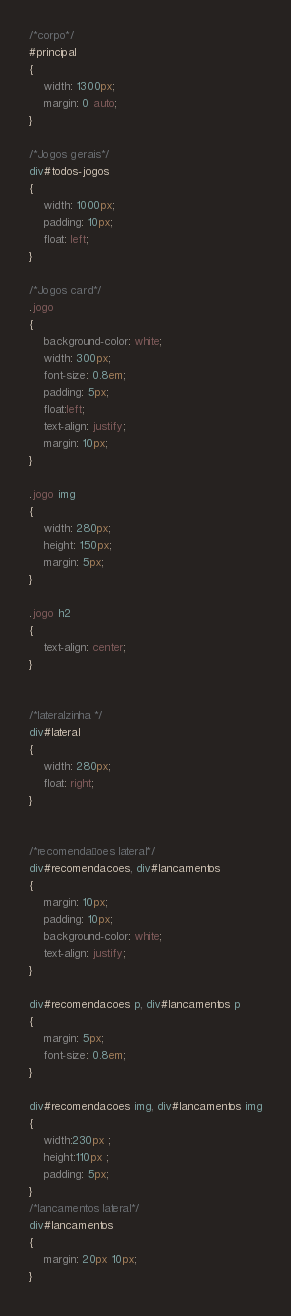Convert code to text. <code><loc_0><loc_0><loc_500><loc_500><_CSS_>
/*corpo*/
#principal
{
    width: 1300px;
    margin: 0 auto;
}

/*Jogos gerais*/
div#todos-jogos
{
    width: 1000px;
    padding: 10px;
    float: left;
}

/*Jogos card*/
.jogo
{
    background-color: white;
    width: 300px;
    font-size: 0.8em;
    padding: 5px;
    float:left;
    text-align: justify;
    margin: 10px;
}

.jogo img
{
    width: 280px;
    height: 150px;
    margin: 5px;
}

.jogo h2
{
    text-align: center;
}


/*lateralzinha */
div#lateral
{
    width: 280px;
    float: right;
}


/*recomendaçoes lateral*/
div#recomendacoes, div#lancamentos
{
    margin: 10px;
    padding: 10px;
    background-color: white;
    text-align: justify;
}

div#recomendacoes p, div#lancamentos p
{
    margin: 5px;
    font-size: 0.8em;
}

div#recomendacoes img, div#lancamentos img
{
    width:230px ;
    height:110px ;
    padding: 5px;
}
/*lancamentos lateral*/
div#lancamentos
{
    margin: 20px 10px;
}</code> 